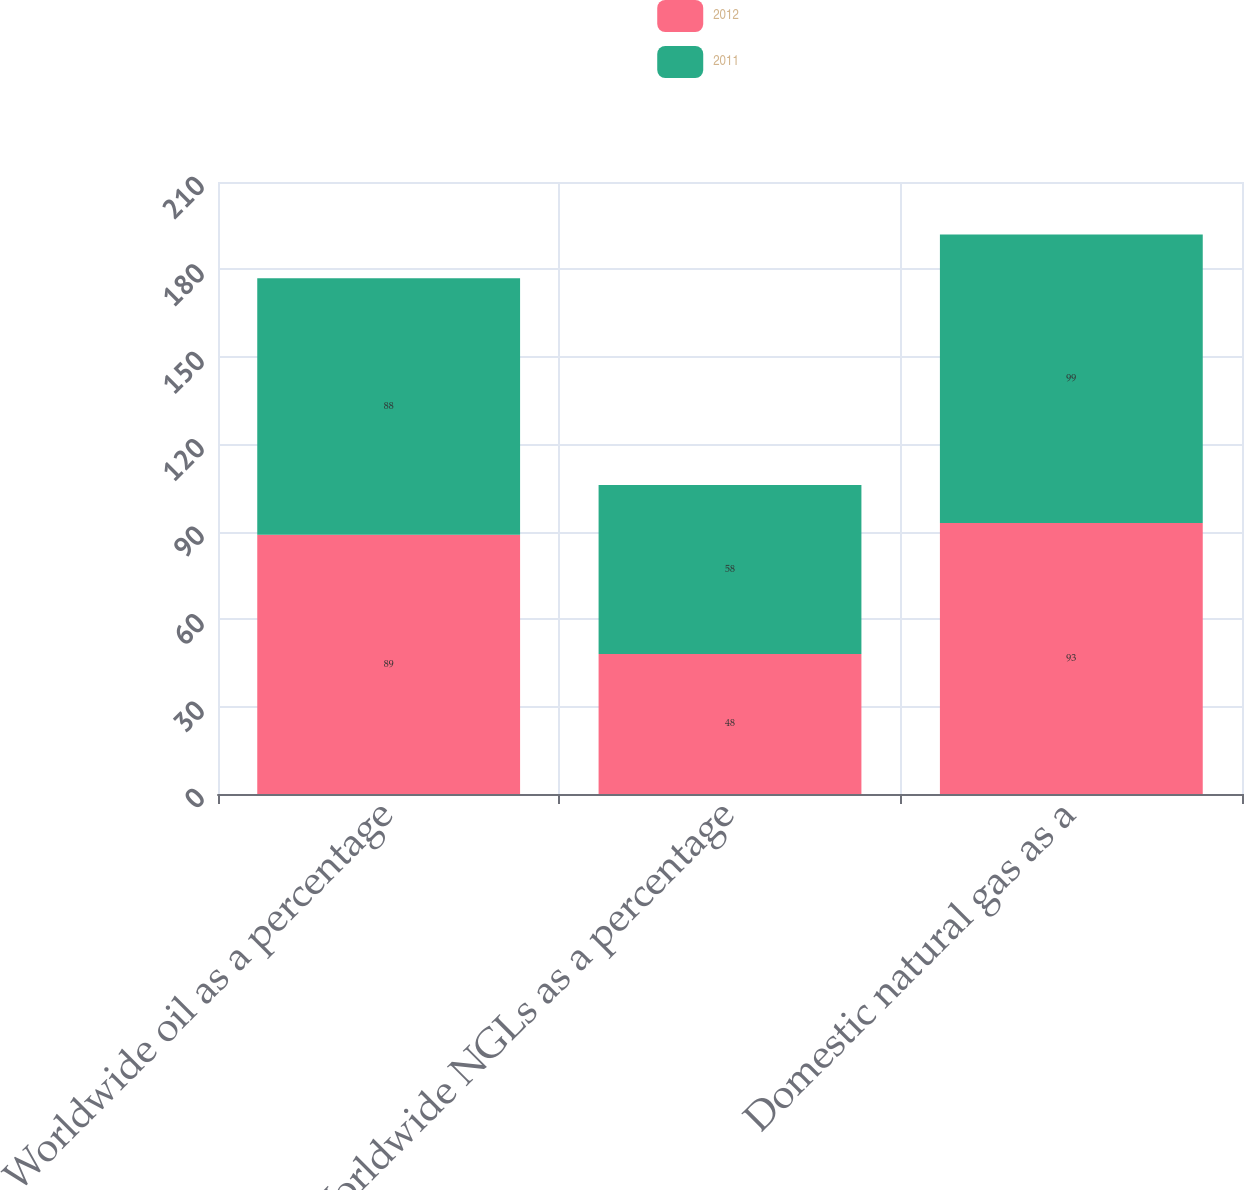<chart> <loc_0><loc_0><loc_500><loc_500><stacked_bar_chart><ecel><fcel>Worldwide oil as a percentage<fcel>Worldwide NGLs as a percentage<fcel>Domestic natural gas as a<nl><fcel>2012<fcel>89<fcel>48<fcel>93<nl><fcel>2011<fcel>88<fcel>58<fcel>99<nl></chart> 